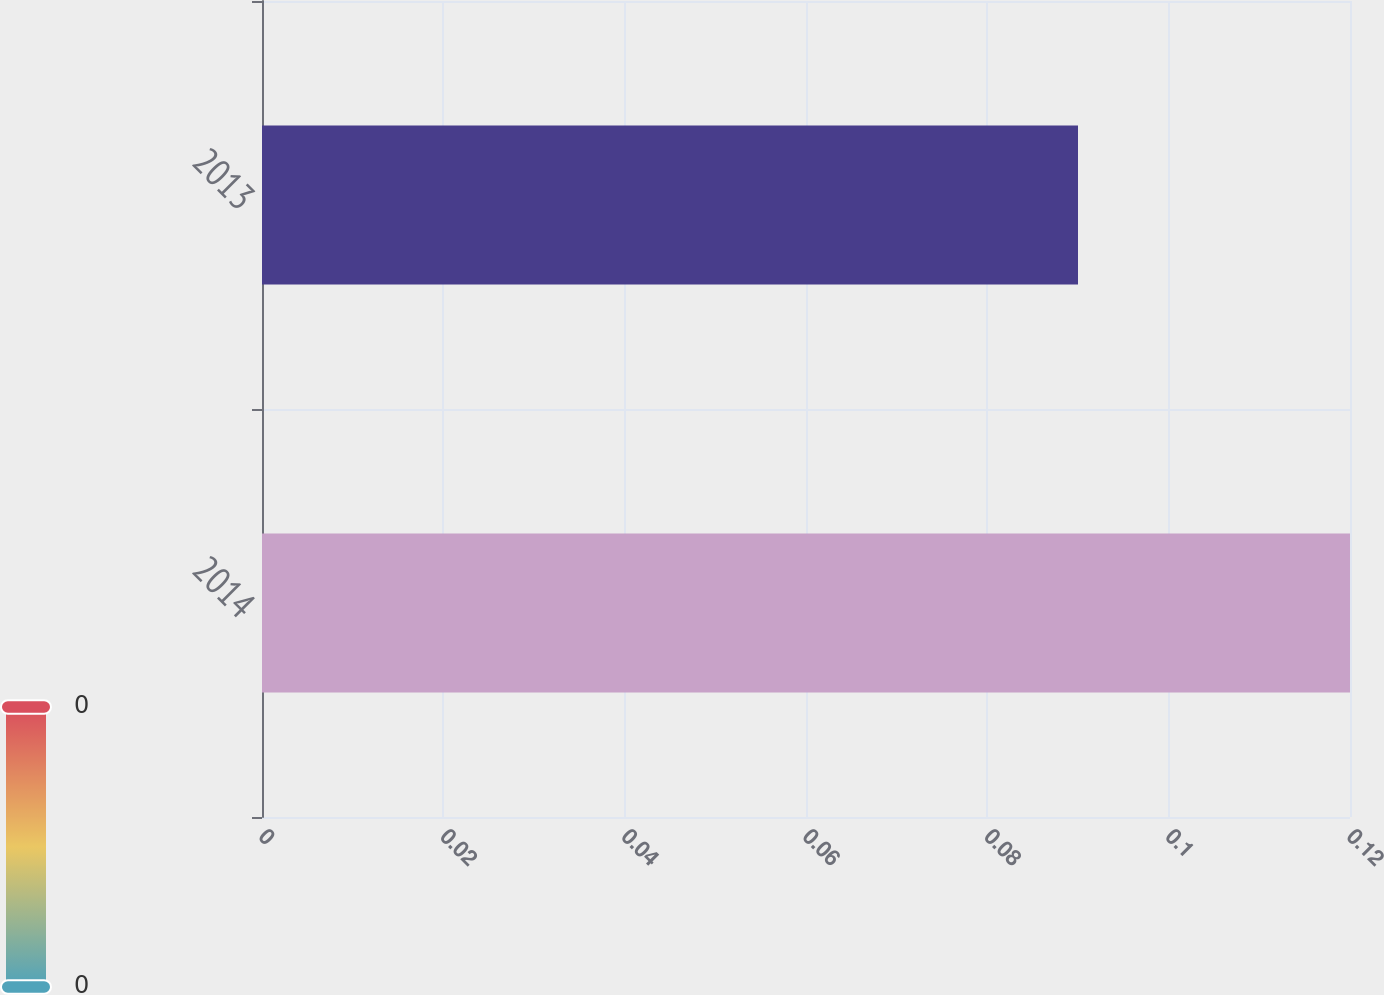<chart> <loc_0><loc_0><loc_500><loc_500><bar_chart><fcel>2014<fcel>2013<nl><fcel>0.12<fcel>0.09<nl></chart> 